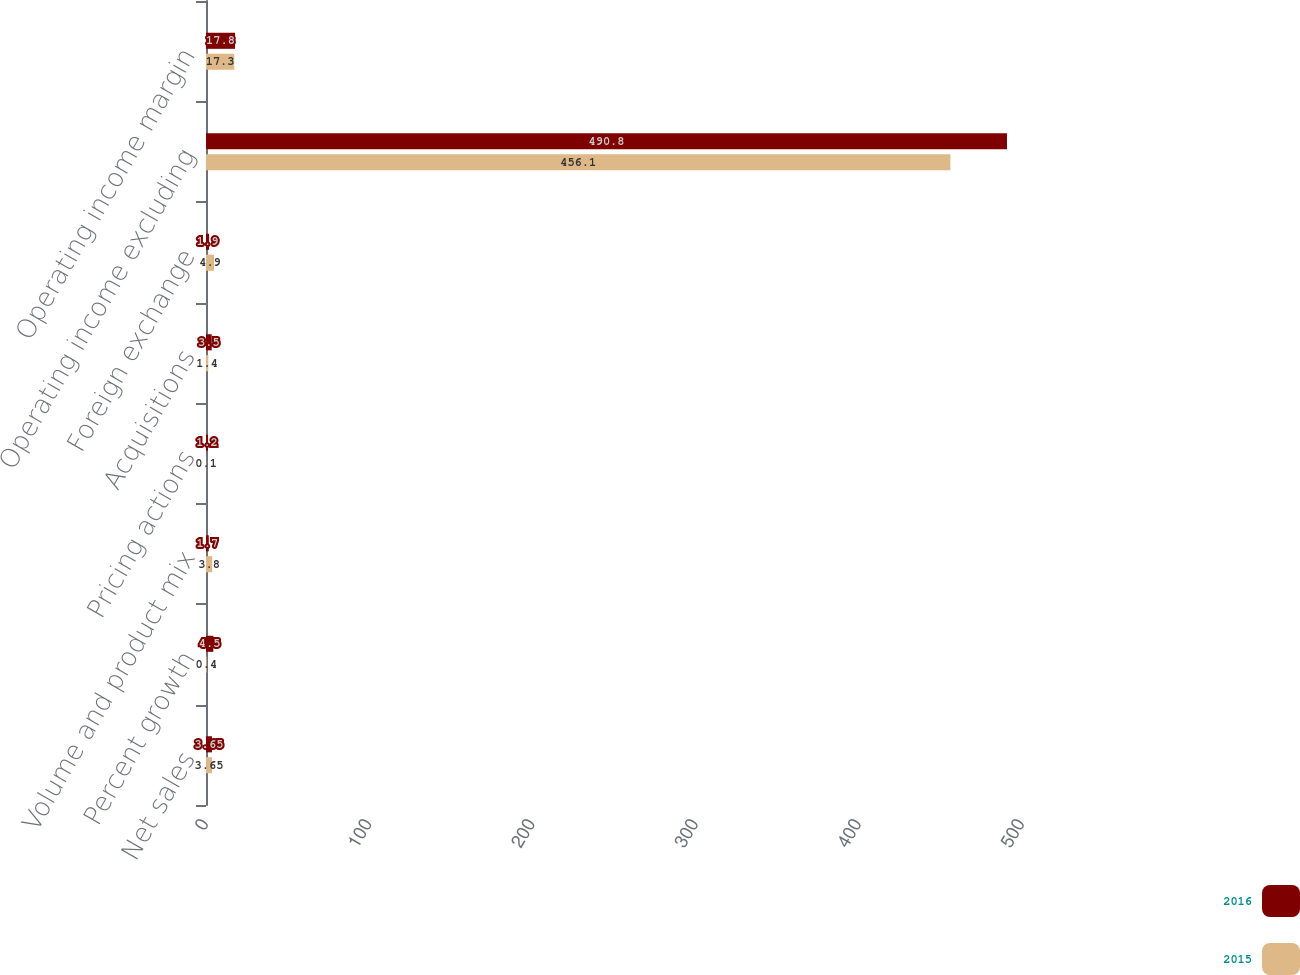Convert chart to OTSL. <chart><loc_0><loc_0><loc_500><loc_500><stacked_bar_chart><ecel><fcel>Net sales<fcel>Percent growth<fcel>Volume and product mix<fcel>Pricing actions<fcel>Acquisitions<fcel>Foreign exchange<fcel>Operating income excluding<fcel>Operating income margin<nl><fcel>2016<fcel>3.65<fcel>4.5<fcel>1.7<fcel>1.2<fcel>3.5<fcel>1.9<fcel>490.8<fcel>17.8<nl><fcel>2015<fcel>3.65<fcel>0.4<fcel>3.8<fcel>0.1<fcel>1.4<fcel>4.9<fcel>456.1<fcel>17.3<nl></chart> 